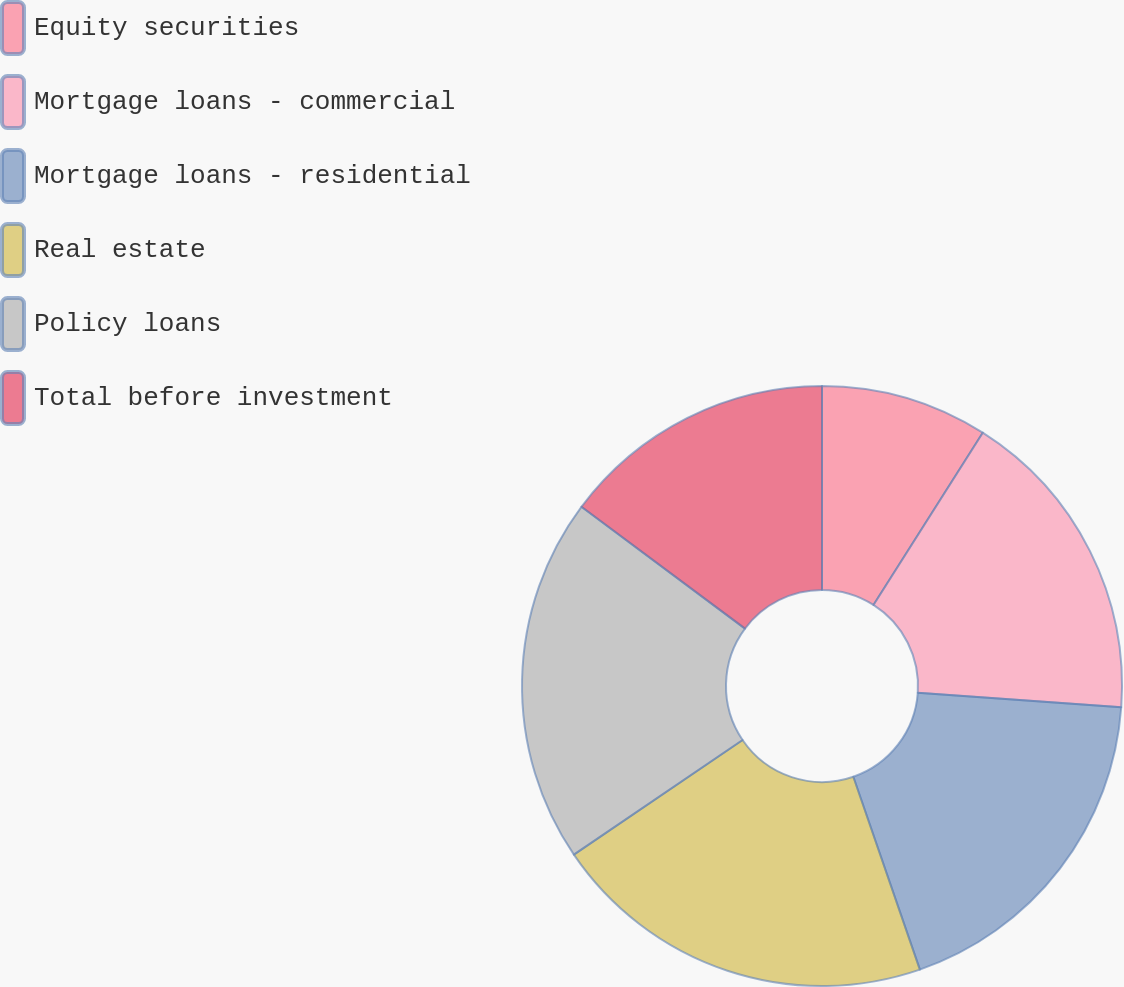<chart> <loc_0><loc_0><loc_500><loc_500><pie_chart><fcel>Equity securities<fcel>Mortgage loans - commercial<fcel>Mortgage loans - residential<fcel>Real estate<fcel>Policy loans<fcel>Total before investment<nl><fcel>9.0%<fcel>17.13%<fcel>18.58%<fcel>20.79%<fcel>19.69%<fcel>14.81%<nl></chart> 